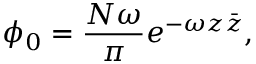Convert formula to latex. <formula><loc_0><loc_0><loc_500><loc_500>\phi _ { 0 } = { \frac { N \omega } { \pi } } e ^ { - \omega z \bar { z } } ,</formula> 